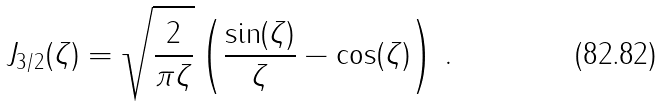Convert formula to latex. <formula><loc_0><loc_0><loc_500><loc_500>J _ { 3 / 2 } ( \zeta ) = \sqrt { \frac { 2 } { \pi \zeta } } \left ( \frac { \sin ( \zeta ) } { \zeta } - \cos ( \zeta ) \right ) \, .</formula> 